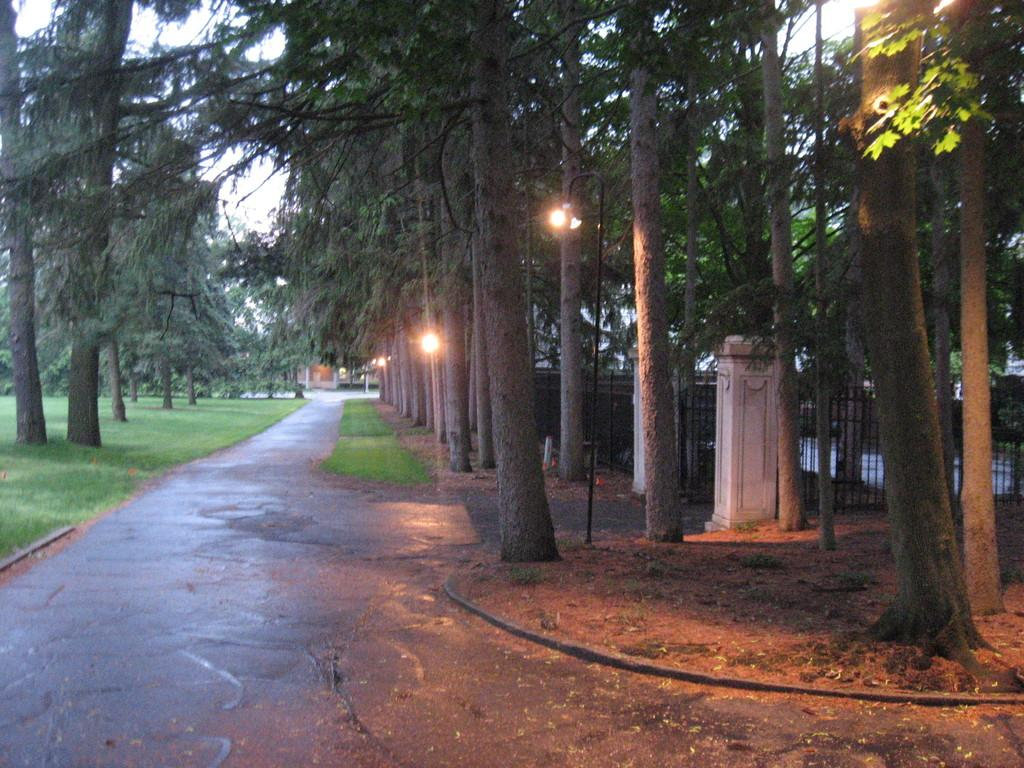What is located in the middle of the image? There is a way in the middle of the image. What can be seen on either side of the way? There are trees on either side of the way. What is present on the right side of the image? There is an iron grill on the right side of the image. What is used to illuminate the trees in the image? There are lights for the trees in the middle of the image. How many sheep can be seen grazing near the ocean in the image? There are no sheep or ocean present in the image. What type of brush is used to clean the iron grill in the image? There is no brush present in the image, and the iron grill is not being cleaned. 